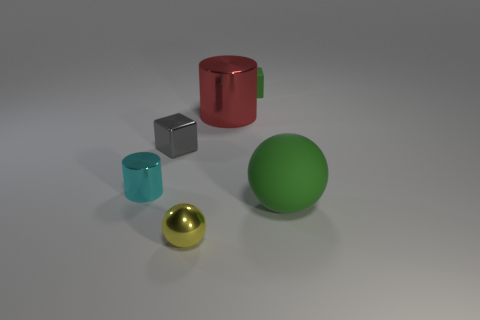Add 3 yellow cylinders. How many objects exist? 9 Subtract all balls. How many objects are left? 4 Subtract 0 blue spheres. How many objects are left? 6 Subtract all tiny metal cylinders. Subtract all small cylinders. How many objects are left? 4 Add 2 small spheres. How many small spheres are left? 3 Add 5 purple matte spheres. How many purple matte spheres exist? 5 